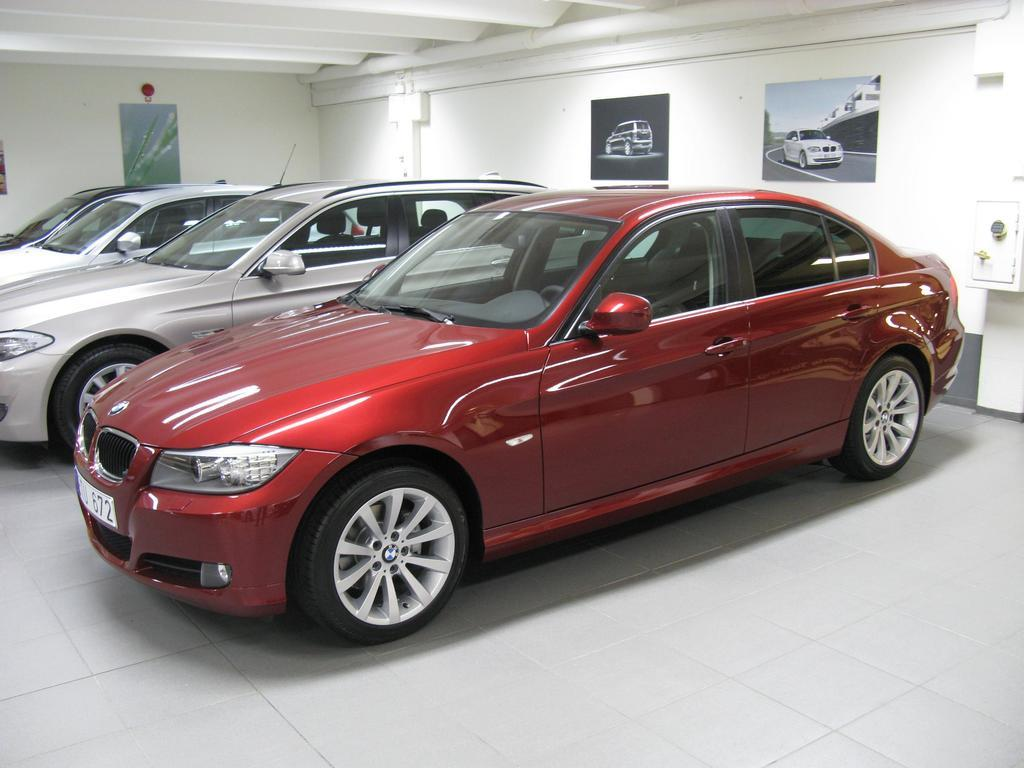What can be seen on the floor in the image? There are cars on a white color floor in the image. What is visible in the background of the image? There is a wall in the background of the image. What is attached to the wall in the image? There are posters attached to the wall. What type of lunch is being served on the cars in the image? There is no lunch present in the image; it features cars on a white floor with a wall and posters in the background. Can you see a giraffe standing next to the cars in the image? There is no giraffe present in the image; it only shows cars on a white floor with a wall and posters in the background. 